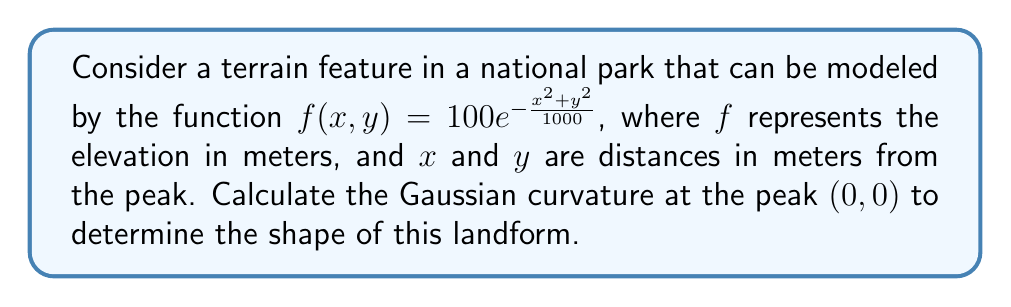Provide a solution to this math problem. To analyze the curvature of this terrain feature, we'll use tensor operations to calculate the Gaussian curvature. The steps are as follows:

1) The Gaussian curvature $K$ is given by:

   $$K = \frac{LN - M^2}{EG - F^2}$$

   where $L$, $M$, $N$ are coefficients of the second fundamental form, and $E$, $F$, $G$ are coefficients of the first fundamental form.

2) For a surface $z = f(x,y)$, these coefficients are:

   $$E = 1 + f_x^2$$
   $$F = f_x f_y$$
   $$G = 1 + f_y^2$$
   $$L = \frac{f_{xx}}{\sqrt{1 + f_x^2 + f_y^2}}$$
   $$M = \frac{f_{xy}}{\sqrt{1 + f_x^2 + f_y^2}}$$
   $$N = \frac{f_{yy}}{\sqrt{1 + f_x^2 + f_y^2}}$$

3) Let's calculate the partial derivatives:

   $$f_x = -\frac{2x}{10}e^{-\frac{x^2+y^2}{1000}}$$
   $$f_y = -\frac{2y}{10}e^{-\frac{x^2+y^2}{1000}}$$
   $$f_{xx} = (-\frac{2}{10} + \frac{4x^2}{10000})e^{-\frac{x^2+y^2}{1000}}$$
   $$f_{yy} = (-\frac{2}{10} + \frac{4y^2}{10000})e^{-\frac{x^2+y^2}{1000}}$$
   $$f_{xy} = \frac{4xy}{10000}e^{-\frac{x^2+y^2}{1000}}$$

4) At the peak $(0,0)$:

   $$f_x = f_y = 0$$
   $$f_{xx} = f_{yy} = -\frac{1}{5}$$
   $$f_{xy} = 0$$

5) Substituting these values:

   $$E = G = 1, F = 0$$
   $$L = N = -\frac{1}{5}, M = 0$$

6) Now we can calculate the Gaussian curvature:

   $$K = \frac{LN - M^2}{EG - F^2} = \frac{(-\frac{1}{5})(-\frac{1}{5}) - 0^2}{1 \cdot 1 - 0^2} = \frac{1}{25} = 0.04$$

The positive Gaussian curvature indicates that this terrain feature is dome-shaped or hill-like at its peak.
Answer: $K = 0.04$ m$^{-2}$ 